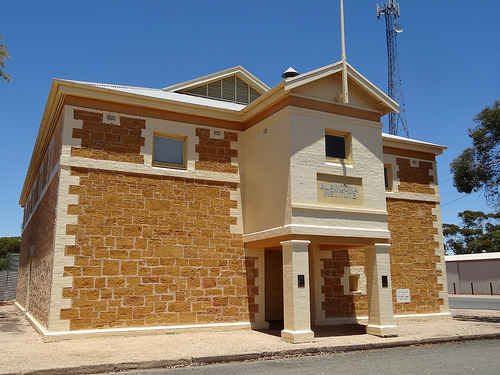<image>
Is the window to the right of the entrance? No. The window is not to the right of the entrance. The horizontal positioning shows a different relationship. 